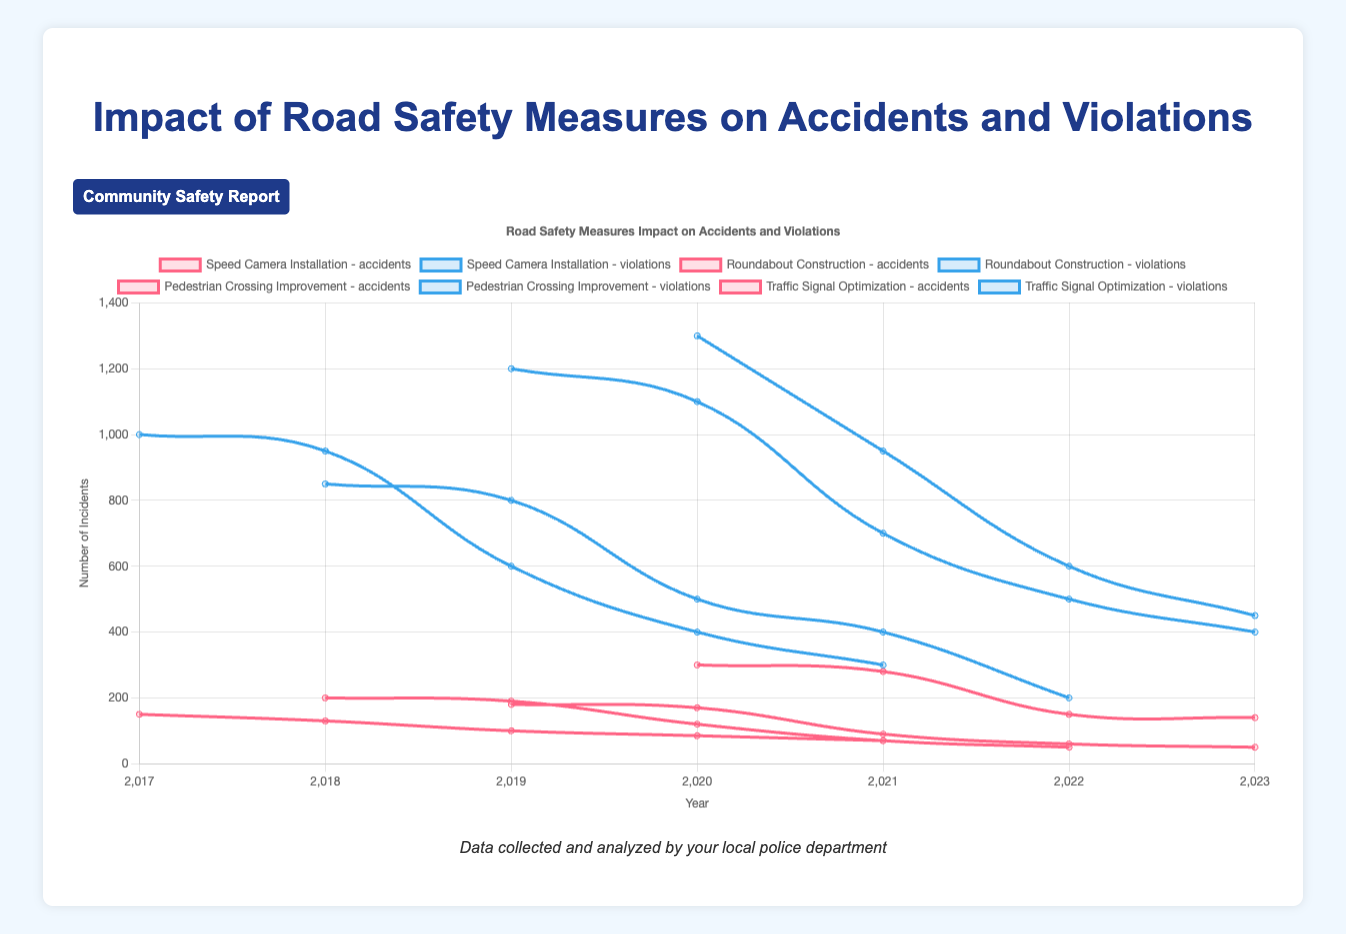Which road safety measure led to the biggest decrease in accidents two years after implementation? First, observe the year of implementation for each measure and then check the accident numbers for the year just before the implementation and two years after. Calculate the difference for each measure: 
- Speed Camera Installation (2018): 150 - 85 = 65
- Roundabout Construction (2019): 200 - 70 = 130
- Pedestrian Crossing Improvement (2020): 180 - 60 = 120
- Traffic Signal Optimization (2021): 300 - 150 = 150
The largest decrease is from Traffic Signal Optimization with a 150 decrease.
Answer: Traffic Signal Optimization In which year did Speed Camera Installation show the most significant reduction in traffic violations? Check the violations data for Speed Camera Installation year-wise and find the year with the largest drop compared to the previous year:
- 2017 to 2018: 1000 - 950 = 50
- 2018 to 2019: 950 - 600 = 350
- 2019 to 2020: 600 - 400 = 200
- 2020 to 2021: 400 - 300 = 100
The biggest drop is from 2018 to 2019.
Answer: 2019 Which road safety measure decreased violations the fastest in the first year after implementation? Look at the year immediately after implementation for each measure and calculate the reduction in violations:
- Speed Camera Installation (2018): 1000 - 950 = 50
- Roundabout Construction (2019): 850 - 800 = 50
- Pedestrian Crossing Improvement (2020): 1200 - 1100 = 100
- Traffic Signal Optimization (2021): 1300 - 950 = 350
The largest drop in the first year is seen in Traffic Signal Optimization.
Answer: Traffic Signal Optimization What is the average number of accidents in the year following all implemented road safety measures? Calculate the average number of accidents in the year immediately after each implementation:
- Speed Camera Installation (2018): 130
- Roundabout Construction (2019): 190
- Pedestrian Crossing Improvement (2020): 170
- Traffic Signal Optimization (2021): 280
Sum these values and divide by the number of measures, (130 + 190 + 170 + 280) / 4 = 770 / 4 = 192.5
Answer: 192.5 Which measure had the smallest reduction in traffic violations from the initial year to the final year of the provided data? Calculate the reduction for each measure from the initial to the final year:
- Speed Camera Installation: 1000 - 300 = 700
- Roundabout Construction: 850 - 200 = 650
- Pedestrian Crossing Improvement: 1200 - 400 = 800
- Traffic Signal Optimization: 1300 - 450 = 850
The smallest reduction is in Roundabout Construction with 650 fewer violations.
Answer: Roundabout Construction For the Speed Camera Installation, what’s the total number of traffic violations recorded from 2018 to 2021? Add up the number of violations recorded in each year from 2018 to 2021:
950 + 600 + 400 + 300 = 2250
Answer: 2250 Which graph line represents the highest initial number of accidents before any measures were implemented? Observe the initial 'accidents' data points before the implementation of measures:
- Speed Camera Installation (150 in 2017)
- Roundabout Construction (200 in 2018)
- Pedestrian Crossing Improvement (180 in 2019)
- Traffic Signal Optimization (300 in 2020)
The highest initial number of accidents is seen in Traffic Signal Optimization with 300 accidents.
Answer: Traffic Signal Optimization Which road safety measure had the most annual changes in both accidents and violations? Count total annual changes for both accidents and violations for each measure (observe the steepest trends on the lines):
- Speed Camera Installation: 4 changes in accidents, 4 in violations (total 8)
- Roundabout Construction: 4 changes in accidents, 4 in violations (total 8)
- Pedestrian Crossing Improvement: 4 changes in accidents, 4 in violations (total 8)
- Traffic Signal Optimization: 3 changes in accidents, 3 in violations (total 6)
Both Speed Camera Installation, Roundabout Construction, and Pedestrian Crossing Improvement had equally most changes.
Answer: Speed Camera Installation, Roundabout Construction, Pedestrian Crossing Improvement 